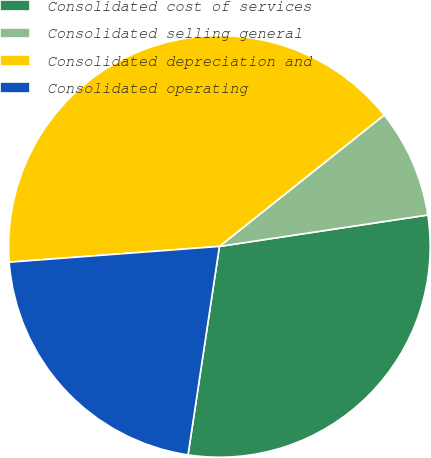Convert chart to OTSL. <chart><loc_0><loc_0><loc_500><loc_500><pie_chart><fcel>Consolidated cost of services<fcel>Consolidated selling general<fcel>Consolidated depreciation and<fcel>Consolidated operating<nl><fcel>29.76%<fcel>8.33%<fcel>40.48%<fcel>21.43%<nl></chart> 